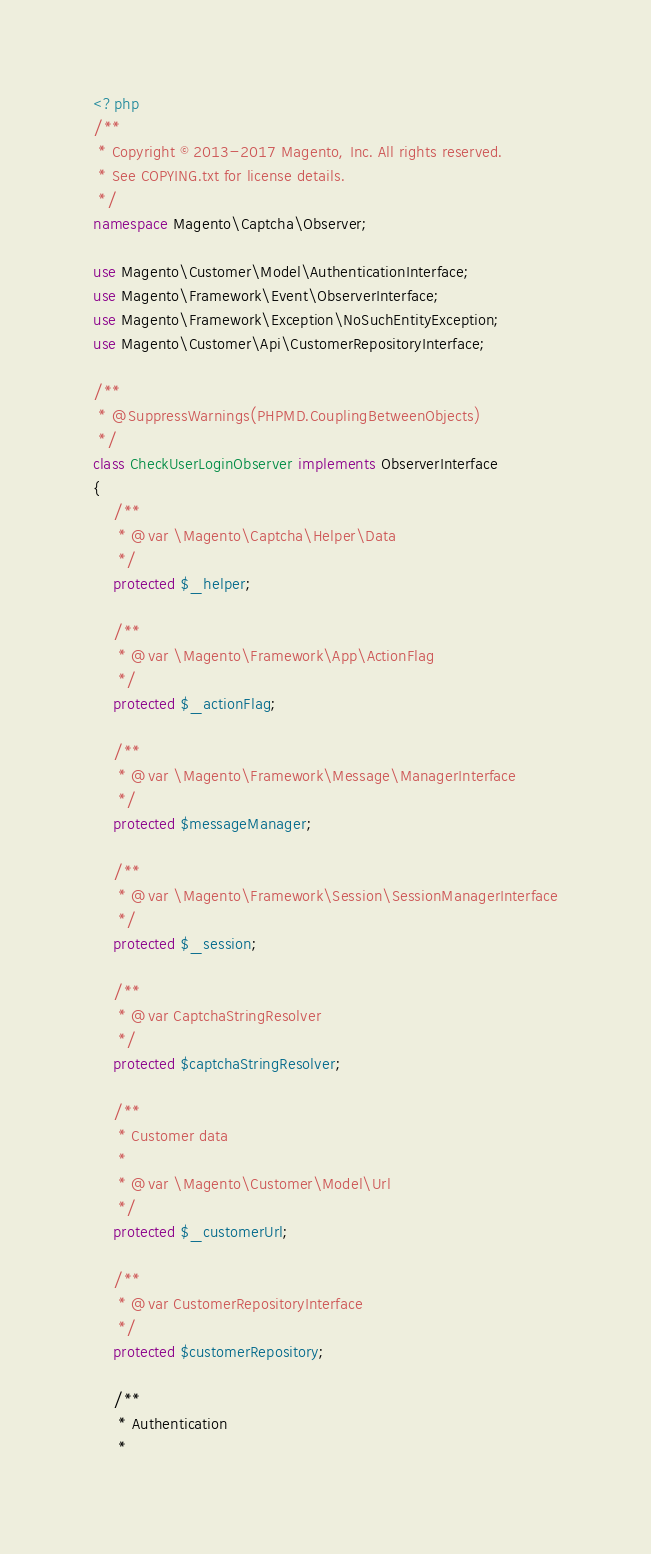<code> <loc_0><loc_0><loc_500><loc_500><_PHP_><?php
/**
 * Copyright © 2013-2017 Magento, Inc. All rights reserved.
 * See COPYING.txt for license details.
 */
namespace Magento\Captcha\Observer;

use Magento\Customer\Model\AuthenticationInterface;
use Magento\Framework\Event\ObserverInterface;
use Magento\Framework\Exception\NoSuchEntityException;
use Magento\Customer\Api\CustomerRepositoryInterface;

/**
 * @SuppressWarnings(PHPMD.CouplingBetweenObjects)
 */
class CheckUserLoginObserver implements ObserverInterface
{
    /**
     * @var \Magento\Captcha\Helper\Data
     */
    protected $_helper;

    /**
     * @var \Magento\Framework\App\ActionFlag
     */
    protected $_actionFlag;

    /**
     * @var \Magento\Framework\Message\ManagerInterface
     */
    protected $messageManager;

    /**
     * @var \Magento\Framework\Session\SessionManagerInterface
     */
    protected $_session;

    /**
     * @var CaptchaStringResolver
     */
    protected $captchaStringResolver;

    /**
     * Customer data
     *
     * @var \Magento\Customer\Model\Url
     */
    protected $_customerUrl;

    /**
     * @var CustomerRepositoryInterface
     */
    protected $customerRepository;

    /**
     * Authentication
     *</code> 